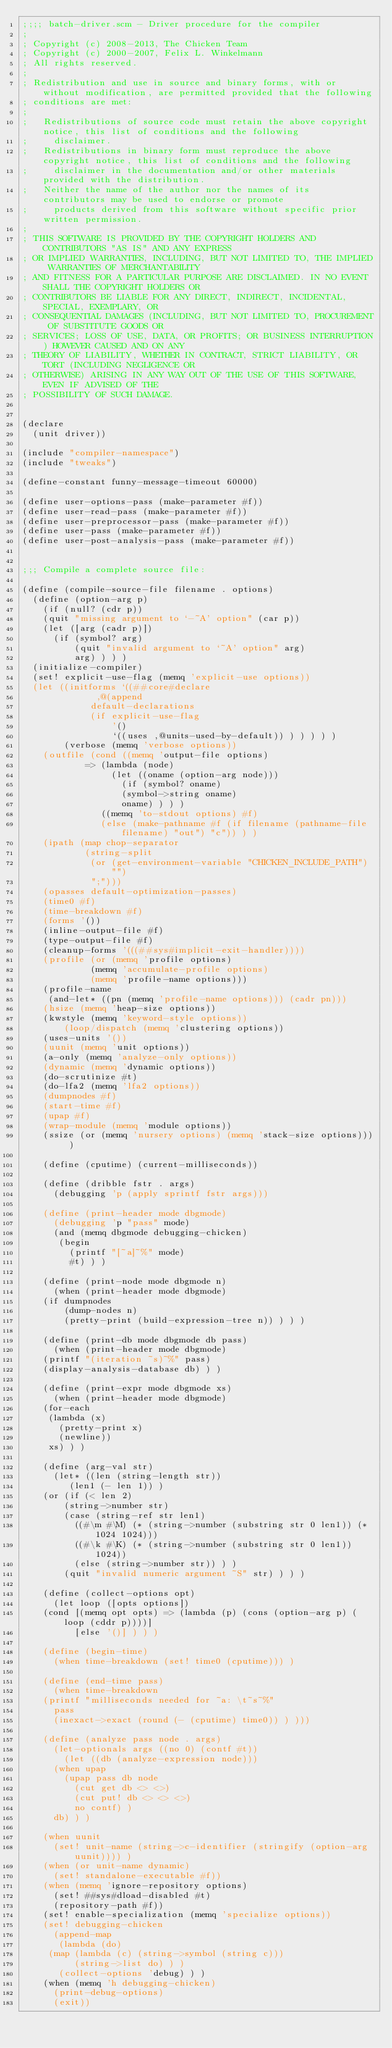Convert code to text. <code><loc_0><loc_0><loc_500><loc_500><_Scheme_>;;;; batch-driver.scm - Driver procedure for the compiler
;
; Copyright (c) 2008-2013, The Chicken Team
; Copyright (c) 2000-2007, Felix L. Winkelmann
; All rights reserved.
;
; Redistribution and use in source and binary forms, with or without modification, are permitted provided that the following
; conditions are met:
;
;   Redistributions of source code must retain the above copyright notice, this list of conditions and the following
;     disclaimer. 
;   Redistributions in binary form must reproduce the above copyright notice, this list of conditions and the following
;     disclaimer in the documentation and/or other materials provided with the distribution. 
;   Neither the name of the author nor the names of its contributors may be used to endorse or promote
;     products derived from this software without specific prior written permission. 
;
; THIS SOFTWARE IS PROVIDED BY THE COPYRIGHT HOLDERS AND CONTRIBUTORS "AS IS" AND ANY EXPRESS
; OR IMPLIED WARRANTIES, INCLUDING, BUT NOT LIMITED TO, THE IMPLIED WARRANTIES OF MERCHANTABILITY
; AND FITNESS FOR A PARTICULAR PURPOSE ARE DISCLAIMED. IN NO EVENT SHALL THE COPYRIGHT HOLDERS OR
; CONTRIBUTORS BE LIABLE FOR ANY DIRECT, INDIRECT, INCIDENTAL, SPECIAL, EXEMPLARY, OR
; CONSEQUENTIAL DAMAGES (INCLUDING, BUT NOT LIMITED TO, PROCUREMENT OF SUBSTITUTE GOODS OR
; SERVICES; LOSS OF USE, DATA, OR PROFITS; OR BUSINESS INTERRUPTION) HOWEVER CAUSED AND ON ANY
; THEORY OF LIABILITY, WHETHER IN CONTRACT, STRICT LIABILITY, OR TORT (INCLUDING NEGLIGENCE OR
; OTHERWISE) ARISING IN ANY WAY OUT OF THE USE OF THIS SOFTWARE, EVEN IF ADVISED OF THE
; POSSIBILITY OF SUCH DAMAGE.


(declare
  (unit driver))

(include "compiler-namespace")
(include "tweaks")

(define-constant funny-message-timeout 60000)

(define user-options-pass (make-parameter #f))
(define user-read-pass (make-parameter #f))
(define user-preprocessor-pass (make-parameter #f))
(define user-pass (make-parameter #f))
(define user-post-analysis-pass (make-parameter #f))


;;; Compile a complete source file:

(define (compile-source-file filename . options)
  (define (option-arg p)
    (if (null? (cdr p))
	(quit "missing argument to `-~A' option" (car p))
	(let ([arg (cadr p)])
	  (if (symbol? arg)
	      (quit "invalid argument to `~A' option" arg)
	      arg) ) ) )
  (initialize-compiler)
  (set! explicit-use-flag (memq 'explicit-use options))
  (let ((initforms `((##core#declare
		      ,@(append 
			 default-declarations
			 (if explicit-use-flag
			     '()
			     `((uses ,@units-used-by-default)) ) ) ) ) )
        (verbose (memq 'verbose options))
	(outfile (cond ((memq 'output-file options) 
			=> (lambda (node)
			     (let ((oname (option-arg node)))
			       (if (symbol? oname)
				   (symbol->string oname)
				   oname) ) ) )
		       ((memq 'to-stdout options) #f)
		       (else (make-pathname #f (if filename (pathname-file filename) "out") "c")) ) )
	(ipath (map chop-separator
		    (string-split 
		     (or (get-environment-variable "CHICKEN_INCLUDE_PATH") "") 
		     ";")))
	(opasses default-optimization-passes)
	(time0 #f)
	(time-breakdown #f)
	(forms '())
	(inline-output-file #f)
	(type-output-file #f)
	(cleanup-forms '(((##sys#implicit-exit-handler))))
	(profile (or (memq 'profile options)
		     (memq 'accumulate-profile options) 
		     (memq 'profile-name options)))
	(profile-name 
	 (and-let* ((pn (memq 'profile-name options))) (cadr pn)))
	(hsize (memq 'heap-size options))
	(kwstyle (memq 'keyword-style options))
        (loop/dispatch (memq 'clustering options))
	(uses-units '())
	(uunit (memq 'unit options))
	(a-only (memq 'analyze-only options))
	(dynamic (memq 'dynamic options))
	(do-scrutinize #t)
	(do-lfa2 (memq 'lfa2 options))
	(dumpnodes #f)
	(start-time #f)
	(upap #f)
	(wrap-module (memq 'module options))
	(ssize (or (memq 'nursery options) (memq 'stack-size options))) )

    (define (cputime) (current-milliseconds))

    (define (dribble fstr . args)
      (debugging 'p (apply sprintf fstr args)))

    (define (print-header mode dbgmode)
      (debugging 'p "pass" mode)
      (and (memq dbgmode debugging-chicken)
	   (begin
	     (printf "[~a]~%" mode)
	     #t) ) )

    (define (print-node mode dbgmode n)
      (when (print-header mode dbgmode)
	(if dumpnodes
	    (dump-nodes n)
	    (pretty-print (build-expression-tree n)) ) ) )

    (define (print-db mode dbgmode db pass)
      (when (print-header mode dbgmode)
	(printf "(iteration ~s)~%" pass)
	(display-analysis-database db) ) )

    (define (print-expr mode dbgmode xs)
      (when (print-header mode dbgmode)
	(for-each 
	 (lambda (x) 
	   (pretty-print x)
	   (newline))
	 xs) ) )

    (define (arg-val str)
      (let* ((len (string-length str))
	     (len1 (- len 1)) )
	(or (if (< len 2)
		(string->number str)
		(case (string-ref str len1)
		  ((#\m #\M) (* (string->number (substring str 0 len1)) (* 1024 1024)))
		  ((#\k #\K) (* (string->number (substring str 0 len1)) 1024))
		  (else (string->number str)) ) )
	    (quit "invalid numeric argument ~S" str) ) ) )

    (define (collect-options opt)
      (let loop ([opts options])
	(cond [(memq opt opts) => (lambda (p) (cons (option-arg p) (loop (cddr p))))]
	      [else '()] ) ) )

    (define (begin-time)
      (when time-breakdown (set! time0 (cputime))) )

    (define (end-time pass)
      (when time-breakdown
	(printf "milliseconds needed for ~a: \t~s~%" 
	  pass
	  (inexact->exact (round (- (cputime) time0)) ) )))

    (define (analyze pass node . args)
      (let-optionals args ((no 0) (contf #t))
        (let ((db (analyze-expression node)))
	  (when upap
	    (upap pass db node
		  (cut get db <> <>)
		  (cut put! db <> <> <>)
		  no contf) )
	  db) ) )

    (when uunit
      (set! unit-name (string->c-identifier (stringify (option-arg uunit)))) )
    (when (or unit-name dynamic)
      (set! standalone-executable #f))
    (when (memq 'ignore-repository options)
      (set! ##sys#dload-disabled #t)
      (repository-path #f))
    (set! enable-specialization (memq 'specialize options))
    (set! debugging-chicken 
      (append-map
       (lambda (do)
	 (map (lambda (c) (string->symbol (string c)))
	      (string->list do) ) )
       (collect-options 'debug) ) )
    (when (memq 'h debugging-chicken)
      (print-debug-options)
      (exit))</code> 